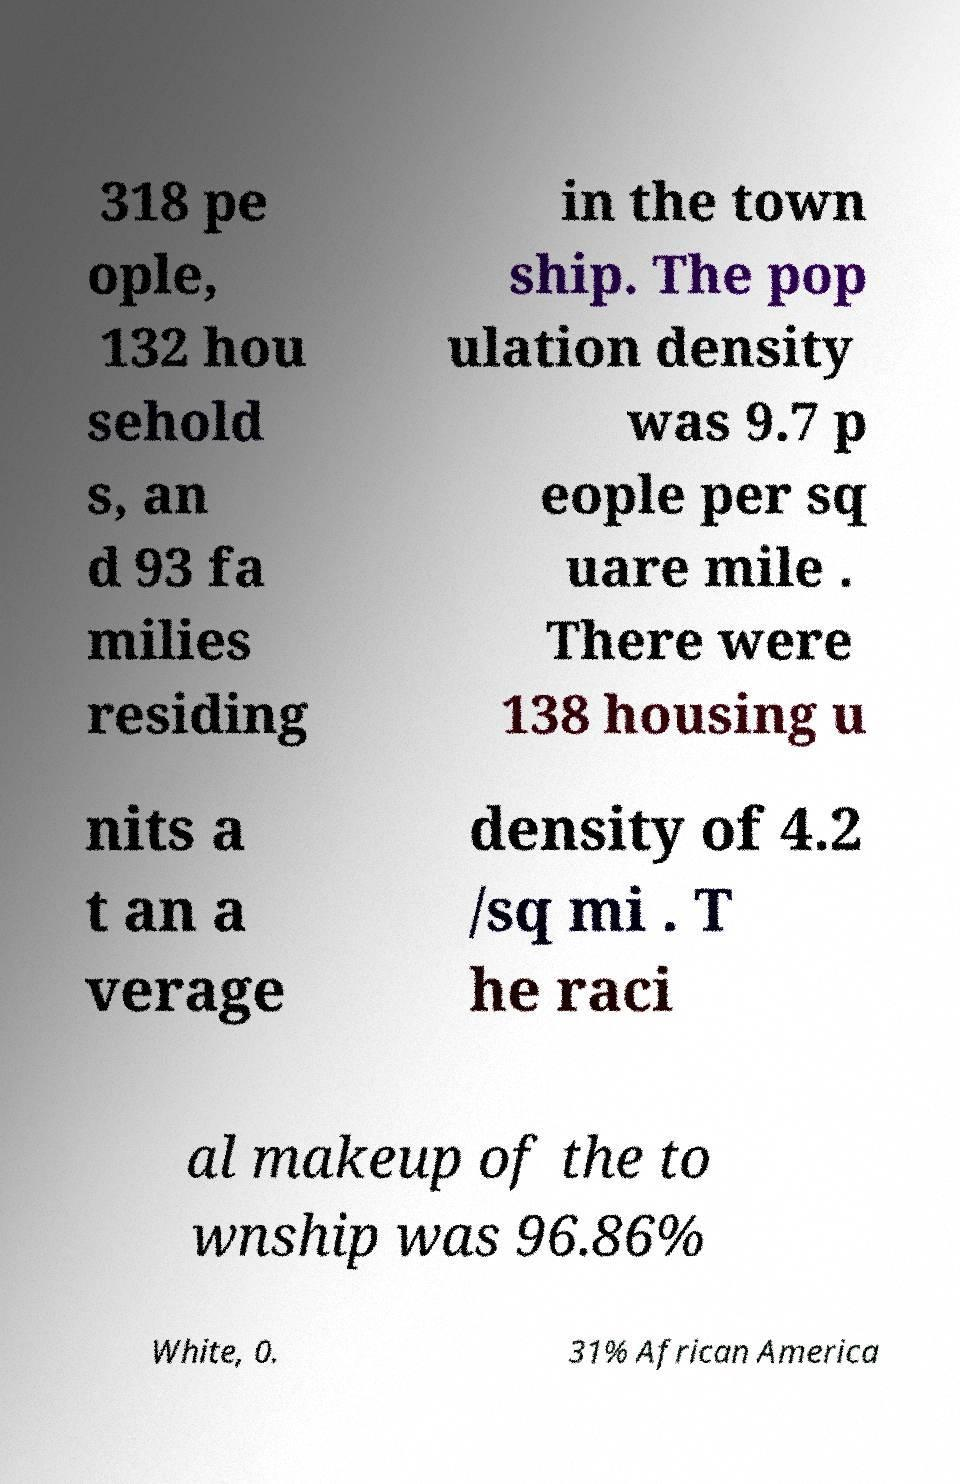For documentation purposes, I need the text within this image transcribed. Could you provide that? 318 pe ople, 132 hou sehold s, an d 93 fa milies residing in the town ship. The pop ulation density was 9.7 p eople per sq uare mile . There were 138 housing u nits a t an a verage density of 4.2 /sq mi . T he raci al makeup of the to wnship was 96.86% White, 0. 31% African America 